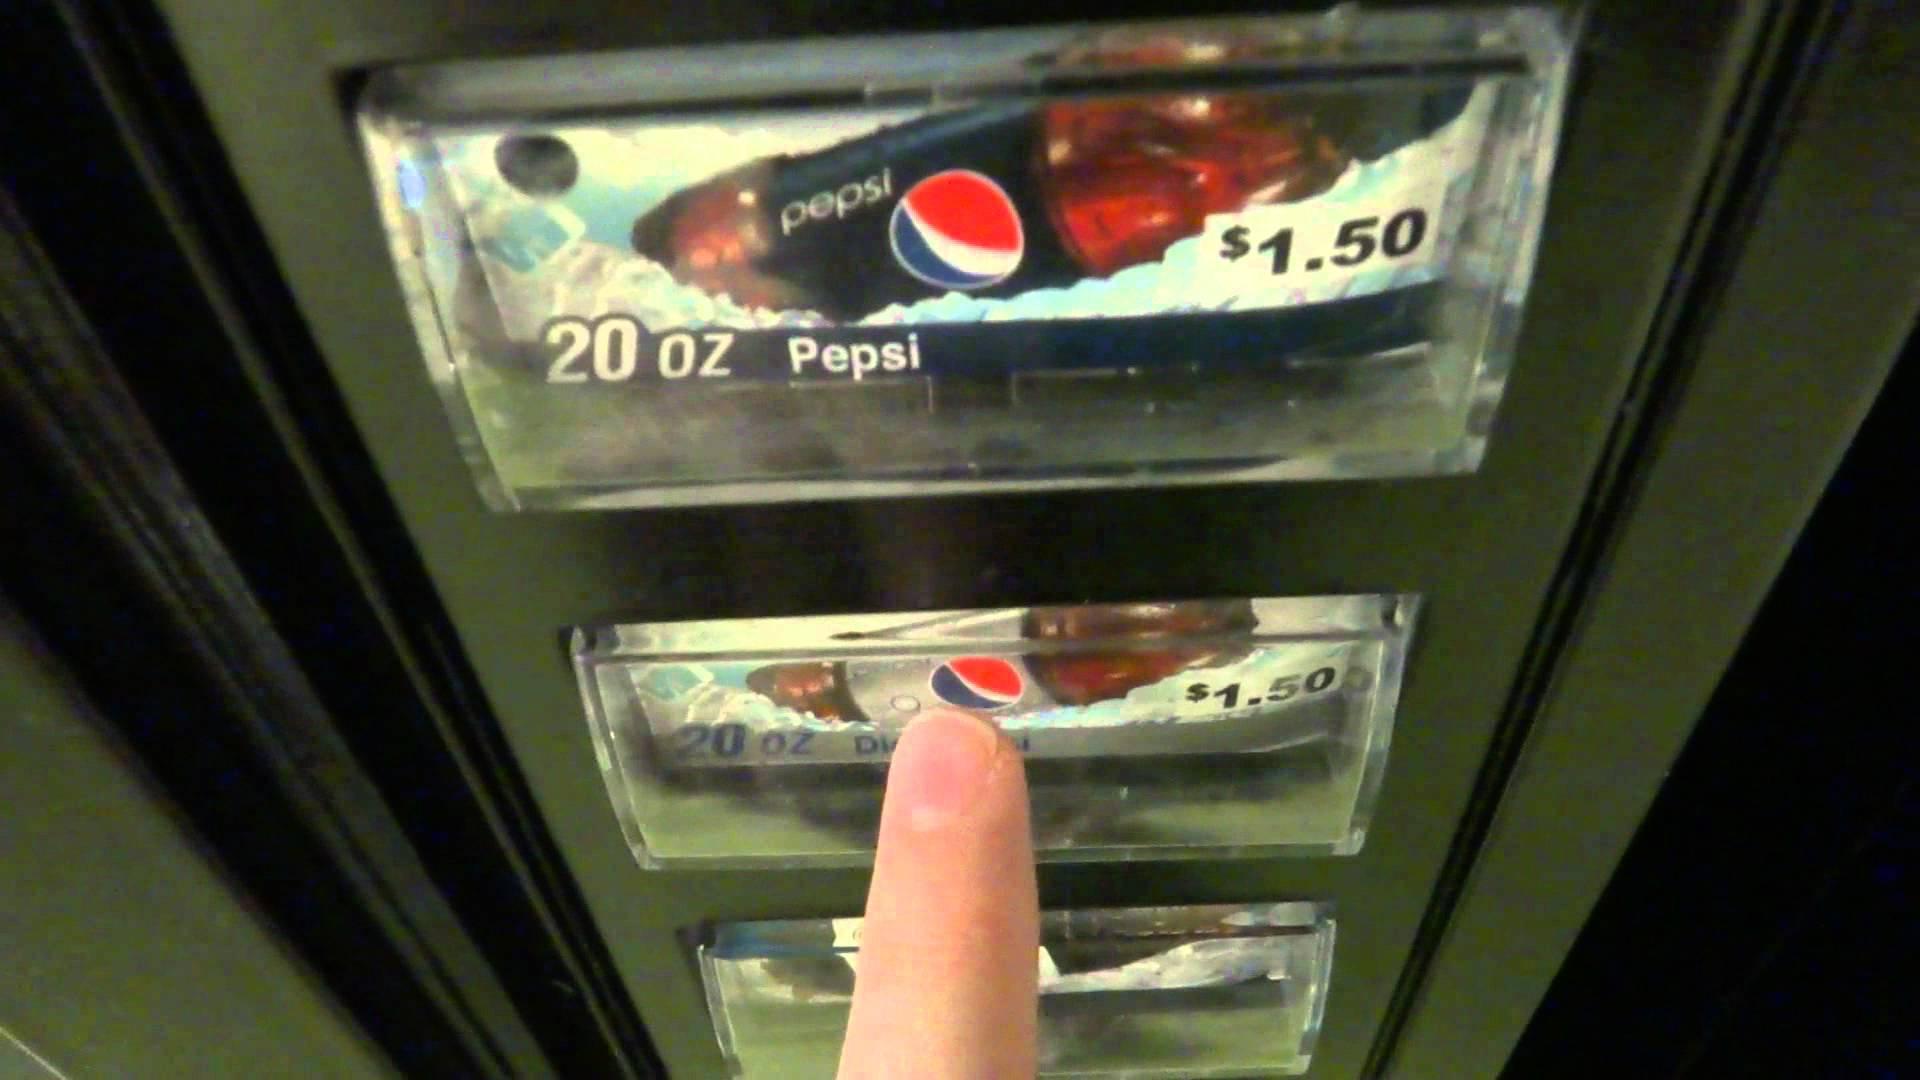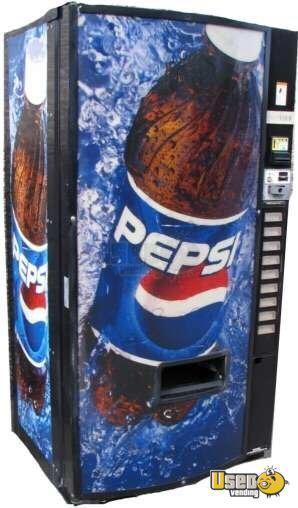The first image is the image on the left, the second image is the image on the right. Analyze the images presented: Is the assertion "All images only show beverages." valid? Answer yes or no. Yes. 